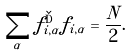<formula> <loc_0><loc_0><loc_500><loc_500>\sum _ { \alpha } f ^ { \dag } _ { i , \alpha } f _ { i , \alpha } = \frac { N } { 2 } .</formula> 